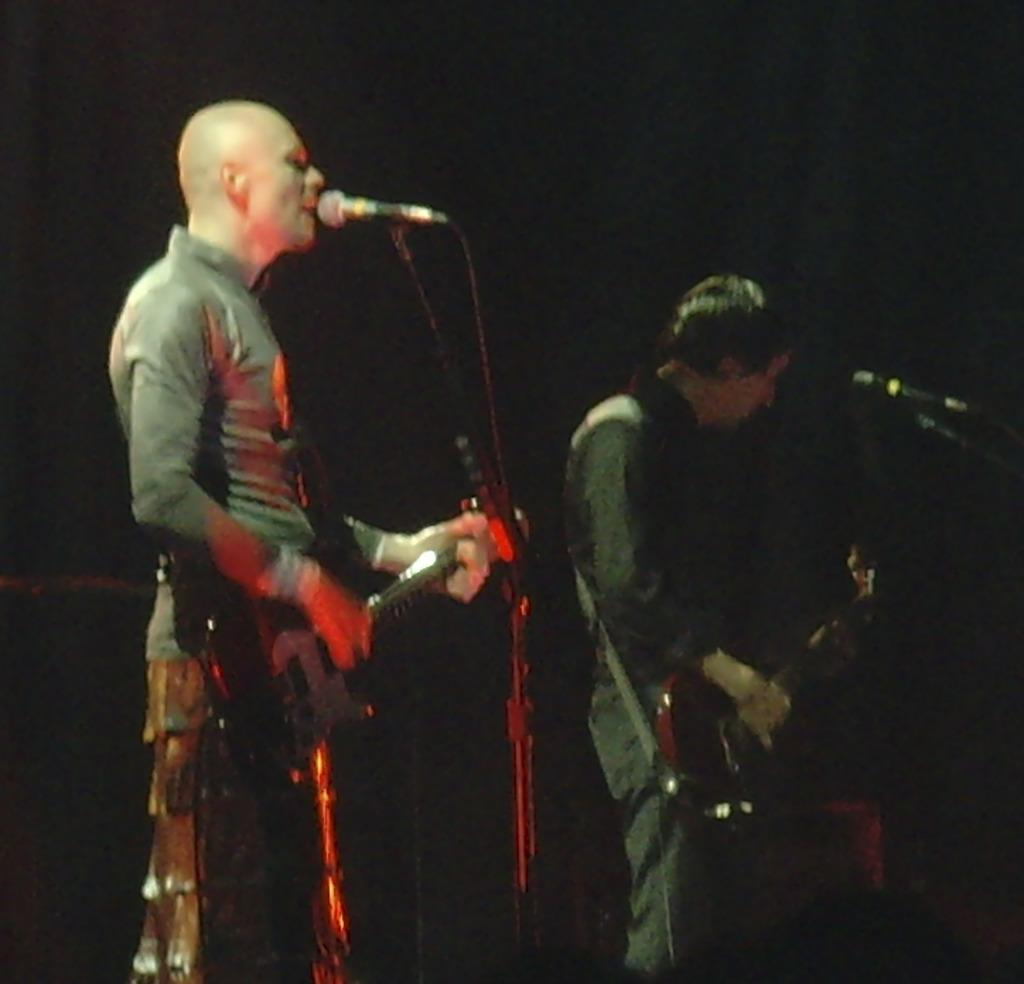How many people are in the image? There are two persons in the image. What are the two persons doing in the image? The two persons are standing in front of a microphone and playing guitar. How many boys are playing the guitar in the image? The provided facts do not mention the gender of the persons in the image, so we cannot determine if they are boys or not. However, there are two persons playing guitar in the image. 